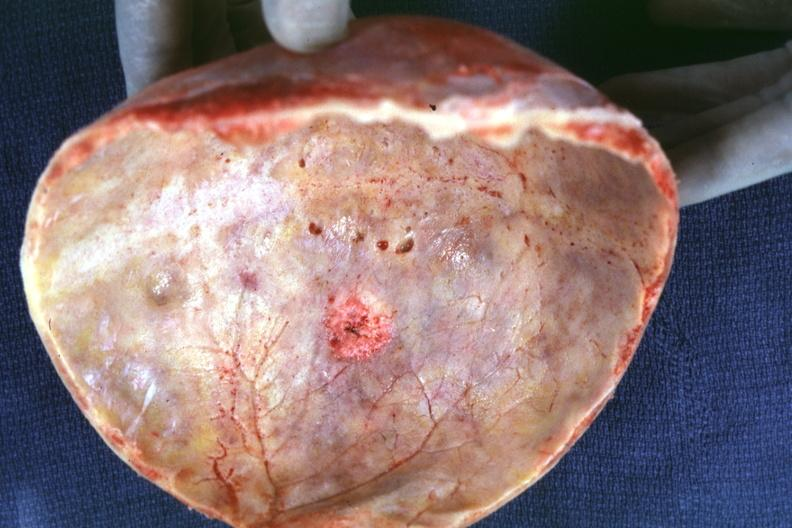s ear lobe horizontal crease present?
Answer the question using a single word or phrase. No 